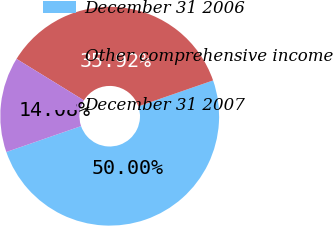<chart> <loc_0><loc_0><loc_500><loc_500><pie_chart><fcel>December 31 2006<fcel>Other comprehensive income<fcel>December 31 2007<nl><fcel>50.0%<fcel>35.92%<fcel>14.08%<nl></chart> 